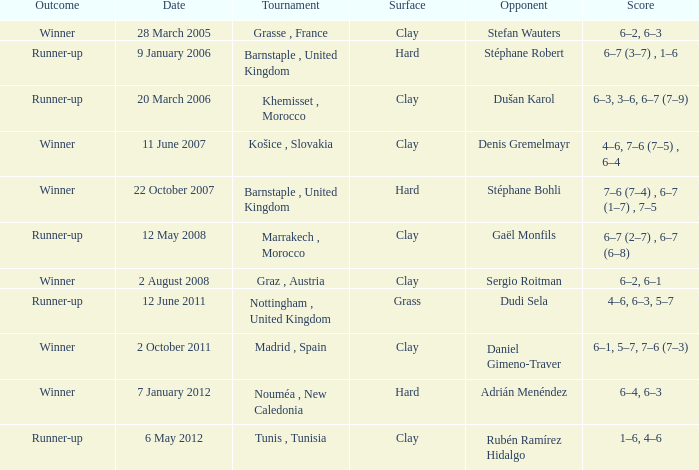What is the score on 2 October 2011? 6–1, 5–7, 7–6 (7–3). 